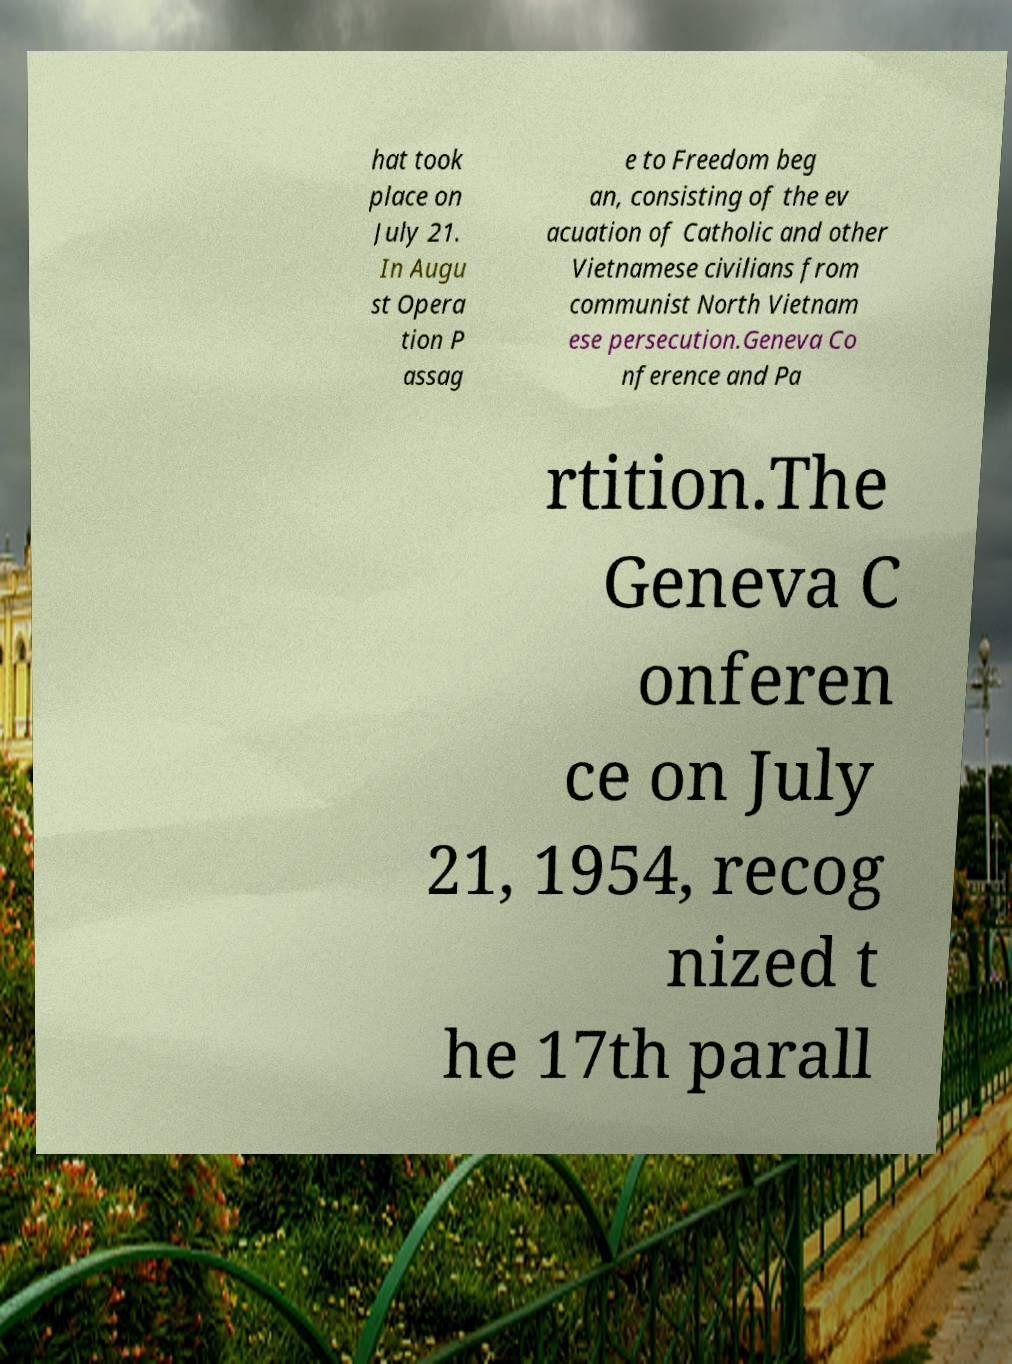There's text embedded in this image that I need extracted. Can you transcribe it verbatim? hat took place on July 21. In Augu st Opera tion P assag e to Freedom beg an, consisting of the ev acuation of Catholic and other Vietnamese civilians from communist North Vietnam ese persecution.Geneva Co nference and Pa rtition.The Geneva C onferen ce on July 21, 1954, recog nized t he 17th parall 